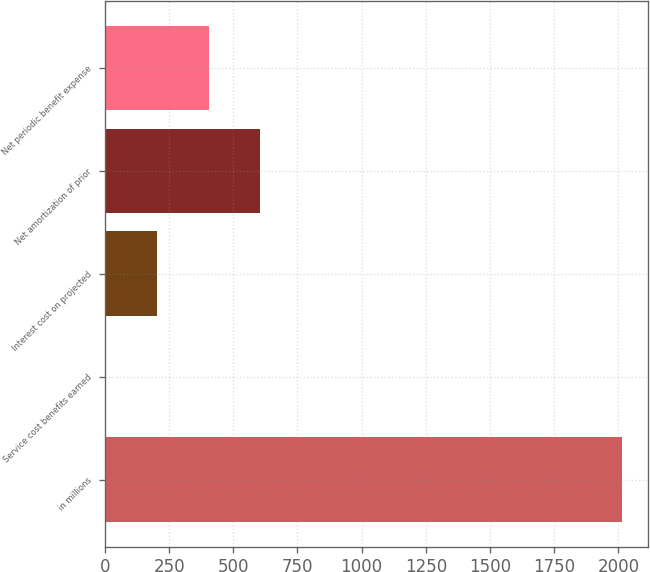Convert chart. <chart><loc_0><loc_0><loc_500><loc_500><bar_chart><fcel>in millions<fcel>Service cost benefits earned<fcel>Interest cost on projected<fcel>Net amortization of prior<fcel>Net periodic benefit expense<nl><fcel>2016<fcel>1<fcel>202.5<fcel>605.5<fcel>404<nl></chart> 